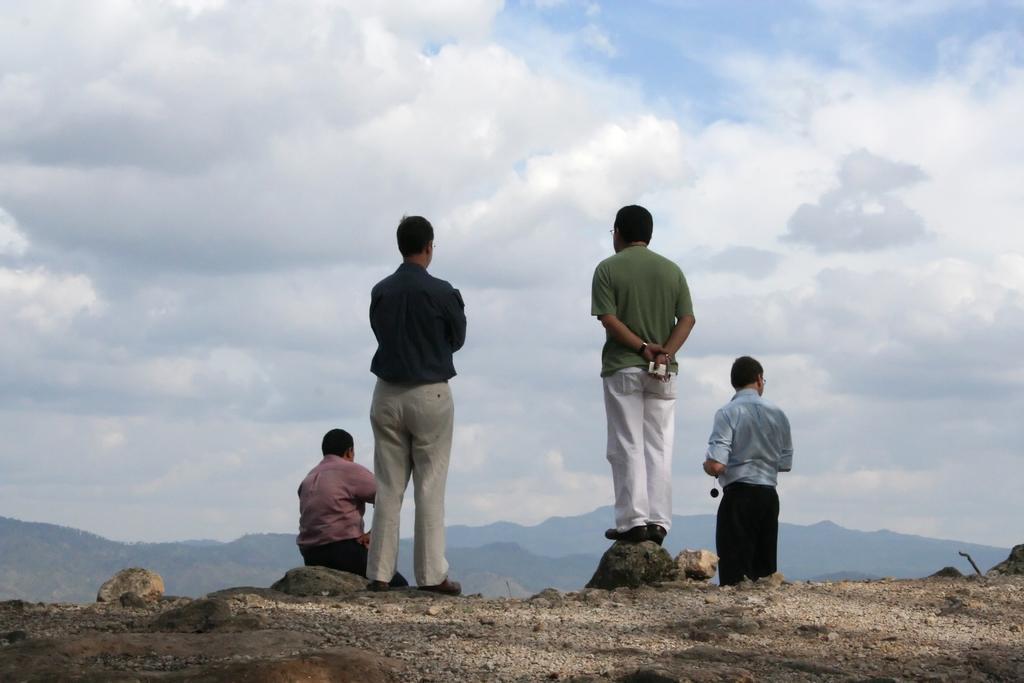Describe this image in one or two sentences. In this image we can see four men. In the background, we can see the sky with clouds and mountains. At the bottom of the image, we can see the land. 